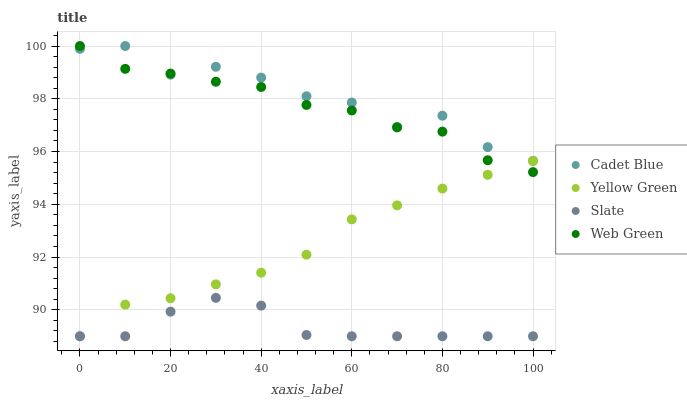Does Slate have the minimum area under the curve?
Answer yes or no. Yes. Does Cadet Blue have the maximum area under the curve?
Answer yes or no. Yes. Does Yellow Green have the minimum area under the curve?
Answer yes or no. No. Does Yellow Green have the maximum area under the curve?
Answer yes or no. No. Is Yellow Green the smoothest?
Answer yes or no. Yes. Is Cadet Blue the roughest?
Answer yes or no. Yes. Is Cadet Blue the smoothest?
Answer yes or no. No. Is Yellow Green the roughest?
Answer yes or no. No. Does Slate have the lowest value?
Answer yes or no. Yes. Does Cadet Blue have the lowest value?
Answer yes or no. No. Does Web Green have the highest value?
Answer yes or no. Yes. Does Yellow Green have the highest value?
Answer yes or no. No. Is Yellow Green less than Cadet Blue?
Answer yes or no. Yes. Is Web Green greater than Slate?
Answer yes or no. Yes. Does Web Green intersect Cadet Blue?
Answer yes or no. Yes. Is Web Green less than Cadet Blue?
Answer yes or no. No. Is Web Green greater than Cadet Blue?
Answer yes or no. No. Does Yellow Green intersect Cadet Blue?
Answer yes or no. No. 